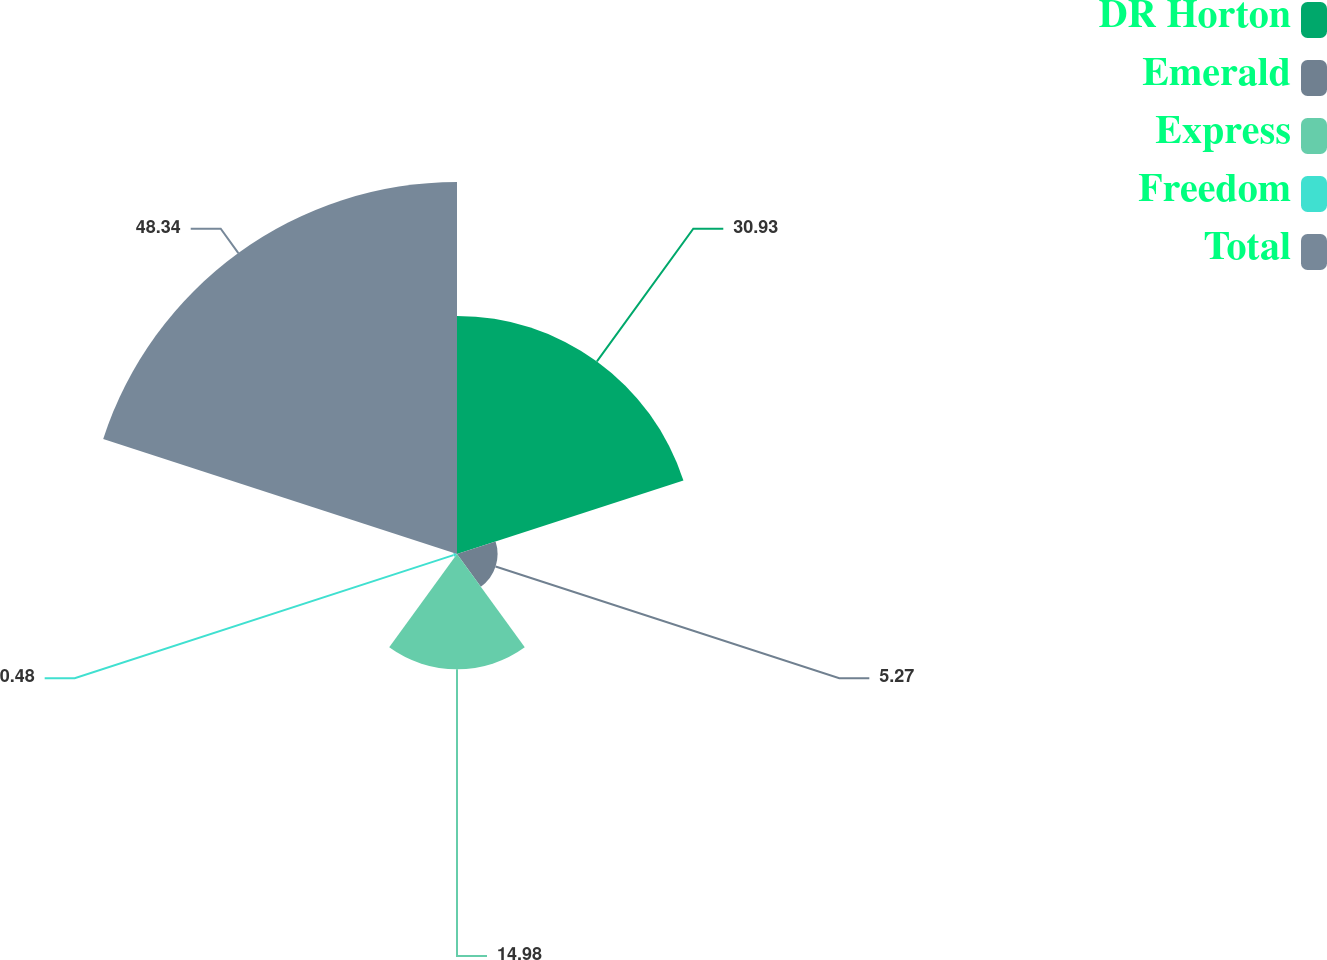Convert chart. <chart><loc_0><loc_0><loc_500><loc_500><pie_chart><fcel>DR Horton<fcel>Emerald<fcel>Express<fcel>Freedom<fcel>Total<nl><fcel>30.93%<fcel>5.27%<fcel>14.98%<fcel>0.48%<fcel>48.33%<nl></chart> 